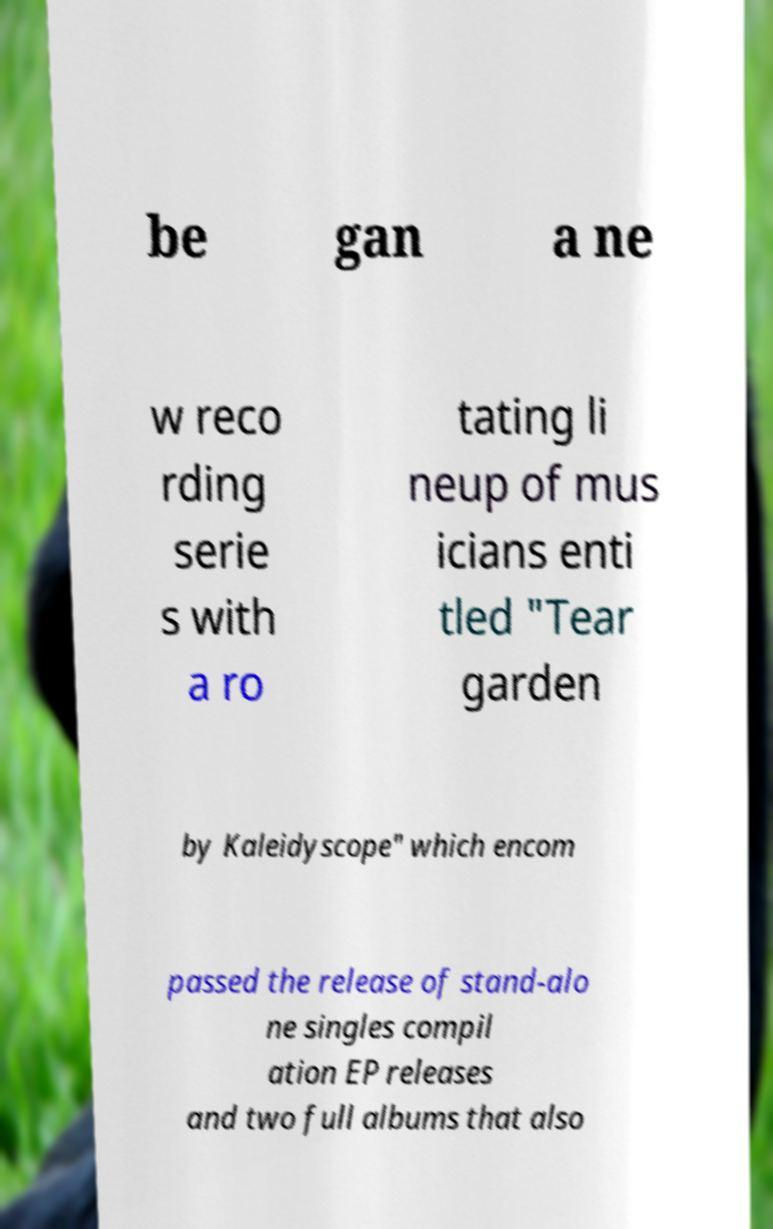Can you read and provide the text displayed in the image?This photo seems to have some interesting text. Can you extract and type it out for me? be gan a ne w reco rding serie s with a ro tating li neup of mus icians enti tled "Tear garden by Kaleidyscope" which encom passed the release of stand-alo ne singles compil ation EP releases and two full albums that also 